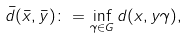<formula> <loc_0><loc_0><loc_500><loc_500>\bar { d } ( \bar { x } , \bar { y } ) \colon = \inf _ { \gamma \in G } d ( x , y \gamma ) ,</formula> 